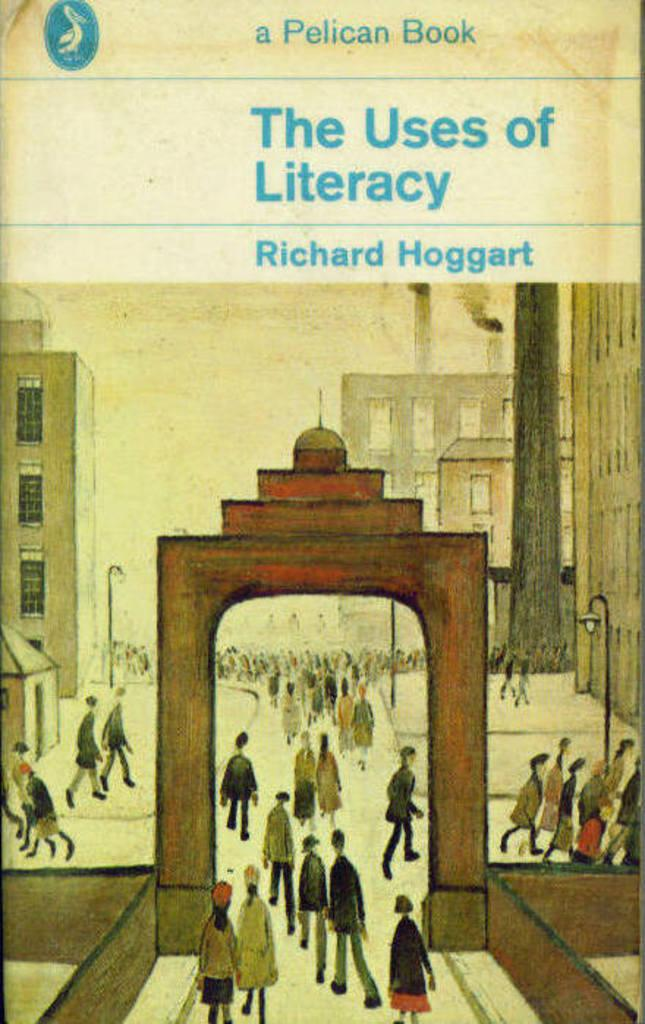What is featured in the image along with the people? In the image, there is a poster, poles, lights, buildings, a wall, and an arch, along with the people. What can be seen at the top of the image? There is text visible at the top of the image. What type of structure is present in the image? There is an arch in the image. What is the purpose of the poles in the image? The purpose of the poles in the image is not explicitly stated, but they may be used for lighting, signage, or other purposes. What color is the eye of the person in the image? There is no eye visible in the image; it only shows a poster, text, people, poles, lights, buildings, a wall, and an arch. What type of business is being conducted in the image? There is no indication of any business being conducted in the image. 